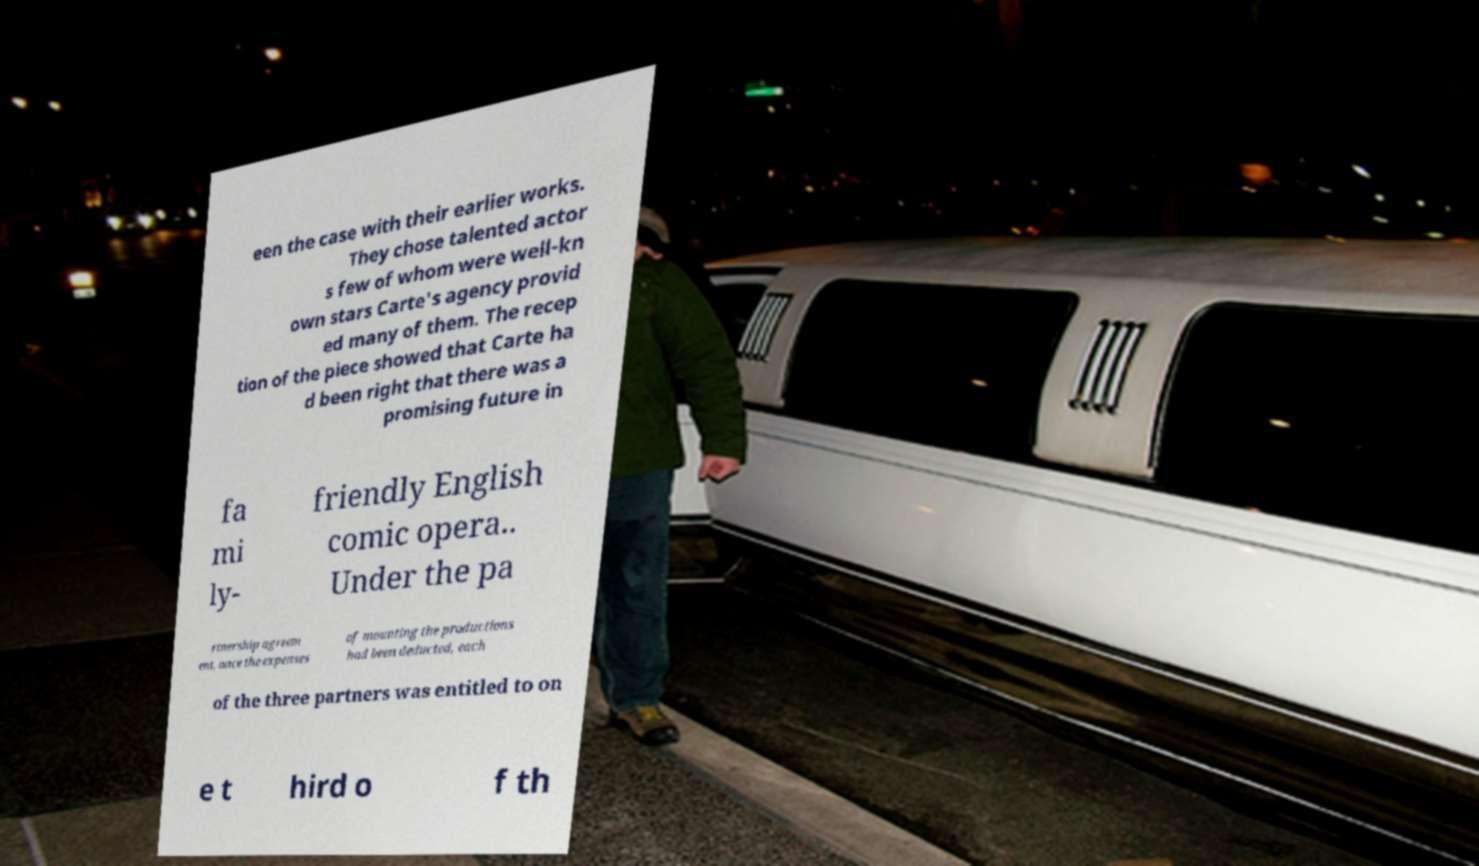Can you accurately transcribe the text from the provided image for me? een the case with their earlier works. They chose talented actor s few of whom were well-kn own stars Carte's agency provid ed many of them. The recep tion of the piece showed that Carte ha d been right that there was a promising future in fa mi ly- friendly English comic opera.. Under the pa rtnership agreem ent, once the expenses of mounting the productions had been deducted, each of the three partners was entitled to on e t hird o f th 